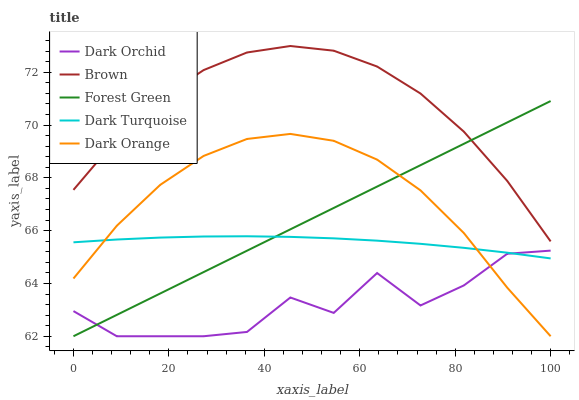Does Dark Orchid have the minimum area under the curve?
Answer yes or no. Yes. Does Brown have the maximum area under the curve?
Answer yes or no. Yes. Does Forest Green have the minimum area under the curve?
Answer yes or no. No. Does Forest Green have the maximum area under the curve?
Answer yes or no. No. Is Forest Green the smoothest?
Answer yes or no. Yes. Is Dark Orchid the roughest?
Answer yes or no. Yes. Is Brown the smoothest?
Answer yes or no. No. Is Brown the roughest?
Answer yes or no. No. Does Dark Orange have the lowest value?
Answer yes or no. Yes. Does Brown have the lowest value?
Answer yes or no. No. Does Brown have the highest value?
Answer yes or no. Yes. Does Forest Green have the highest value?
Answer yes or no. No. Is Dark Orange less than Brown?
Answer yes or no. Yes. Is Brown greater than Dark Orange?
Answer yes or no. Yes. Does Forest Green intersect Dark Orchid?
Answer yes or no. Yes. Is Forest Green less than Dark Orchid?
Answer yes or no. No. Is Forest Green greater than Dark Orchid?
Answer yes or no. No. Does Dark Orange intersect Brown?
Answer yes or no. No. 